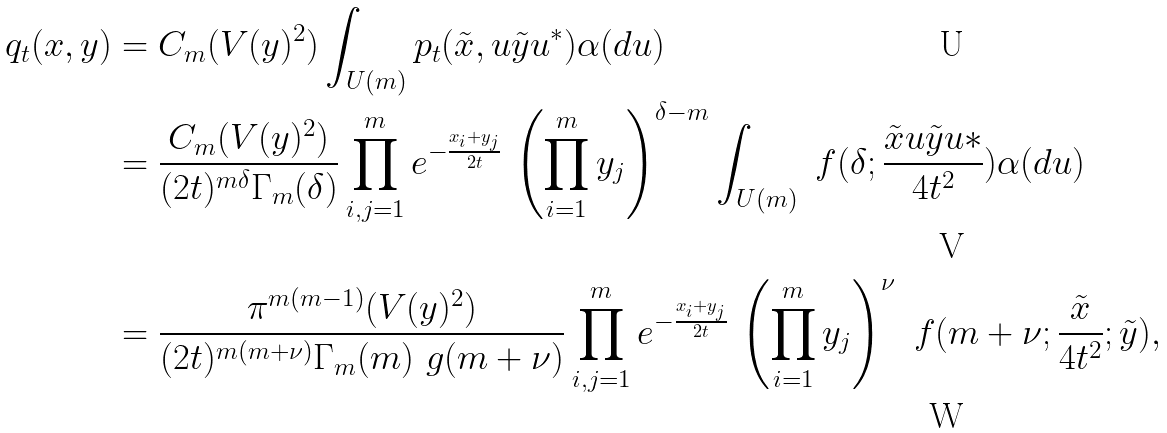<formula> <loc_0><loc_0><loc_500><loc_500>q _ { t } ( x , y ) & = C _ { m } ( V ( y ) ^ { 2 } ) \int _ { U ( m ) } p _ { t } ( \tilde { x } , u \tilde { y } u ^ { * } ) \alpha ( d u ) \\ & = \frac { C _ { m } ( V ( y ) ^ { 2 } ) } { ( 2 t ) ^ { m \delta } \Gamma _ { m } ( \delta ) } \prod _ { i , j = 1 } ^ { m } e ^ { - \frac { x _ { i } + y _ { j } } { 2 t } } \, \left ( \prod _ { i = 1 } ^ { m } y _ { j } \right ) ^ { \delta - m } \int _ { U ( m ) } \ f ( \delta ; \frac { \tilde { x } u \tilde { y } u * } { 4 t ^ { 2 } } ) \alpha ( d u ) \\ & = \frac { \pi ^ { m ( m - 1 ) } ( V ( y ) ^ { 2 } ) } { ( 2 t ) ^ { m ( m + \nu ) } \Gamma _ { m } ( m ) \ g ( m + \nu ) } \prod _ { i , j = 1 } ^ { m } e ^ { - \frac { x _ { i } + y _ { j } } { 2 t } } \, \left ( \prod _ { i = 1 } ^ { m } y _ { j } \right ) ^ { \nu } \ f ( m + \nu ; \frac { \tilde { x } } { 4 t ^ { 2 } } ; \tilde { y } ) ,</formula> 